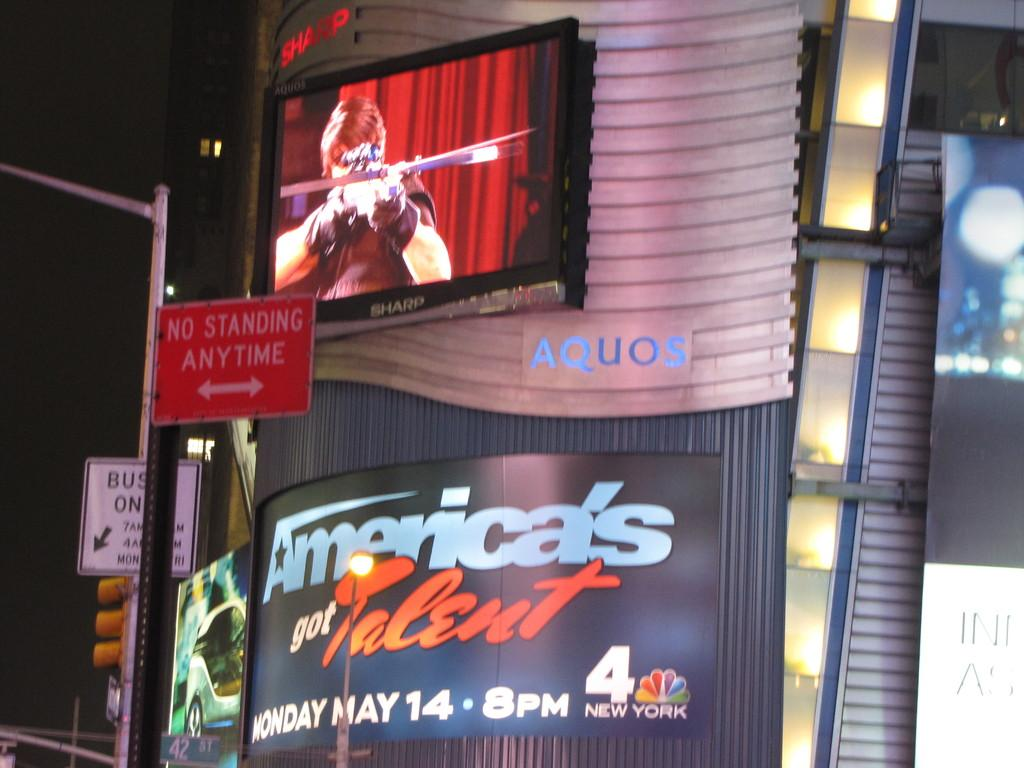Provide a one-sentence caption for the provided image. A LITE MARQUE ON THE STREET OF AMERICAS GOT TALET. 